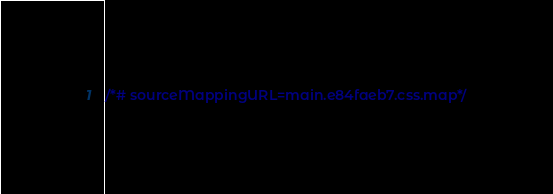<code> <loc_0><loc_0><loc_500><loc_500><_CSS_>/*# sourceMappingURL=main.e84faeb7.css.map*/</code> 